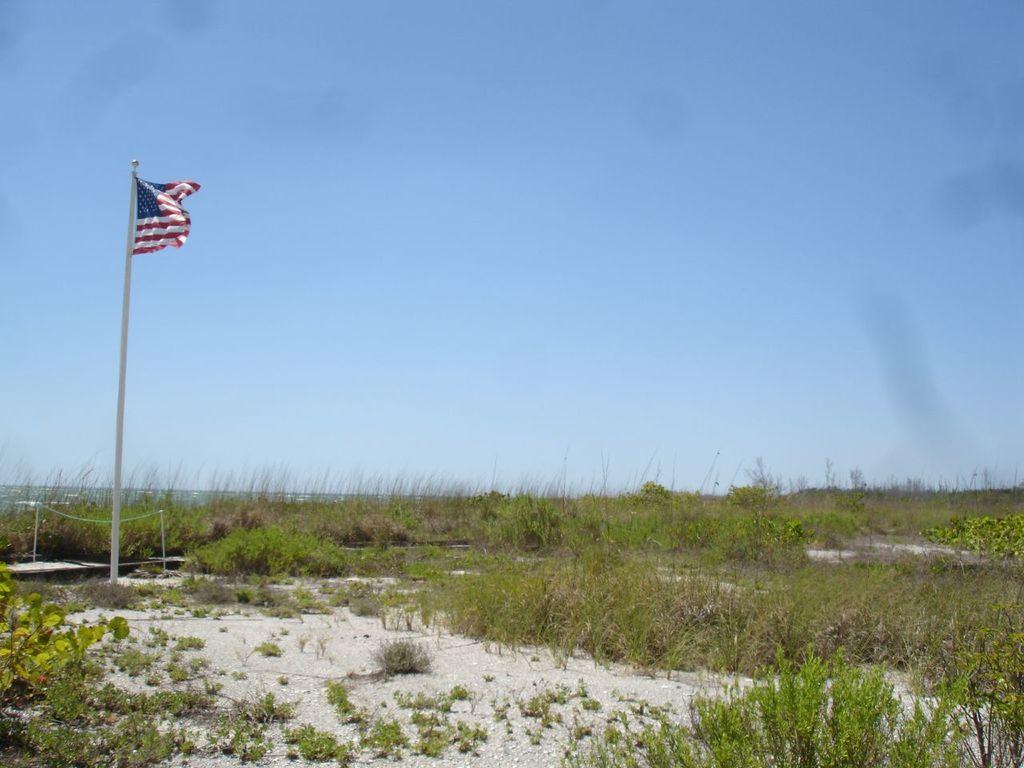Could you give a brief overview of what you see in this image? On the left side of the image we can see a flag. At the bottom there is grass. In the background there is sky and we can see plants. 